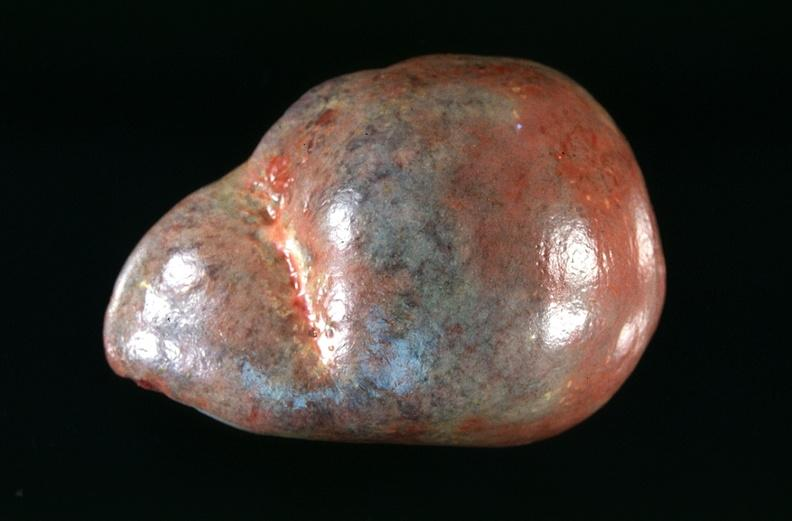what does this image show?
Answer the question using a single word or phrase. Spleen 